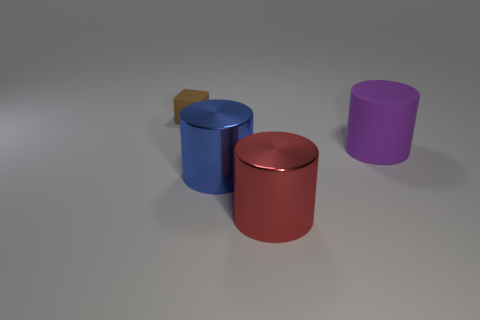There is another metallic thing that is the same shape as the big red object; what color is it?
Your answer should be compact. Blue. Is the rubber block the same size as the blue cylinder?
Your response must be concise. No. There is a big thing that is right of the large red object; what material is it?
Give a very brief answer. Rubber. What number of other things are the same shape as the large blue thing?
Keep it short and to the point. 2. Do the big rubber thing and the red metal object have the same shape?
Provide a succinct answer. Yes. Are there any large blue shiny cylinders left of the blue metal thing?
Provide a succinct answer. No. How many objects are blue objects or purple things?
Provide a succinct answer. 2. What number of other objects are the same size as the purple thing?
Make the answer very short. 2. How many things are in front of the large blue cylinder and to the right of the large red shiny cylinder?
Provide a short and direct response. 0. There is a matte object that is in front of the small brown cube; does it have the same size as the metal cylinder that is to the left of the red metallic cylinder?
Your answer should be compact. Yes. 